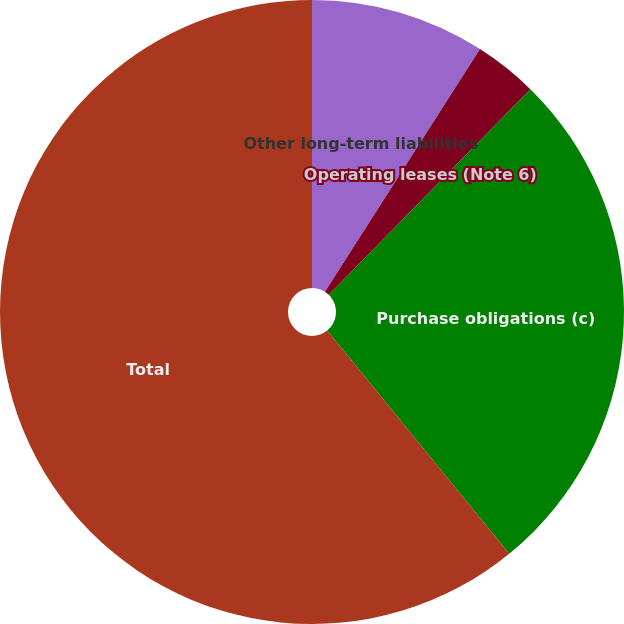<chart> <loc_0><loc_0><loc_500><loc_500><pie_chart><fcel>Other long-term liabilities<fcel>Operating leases (Note 6)<fcel>Purchase obligations (c)<fcel>Total<nl><fcel>9.05%<fcel>3.29%<fcel>26.77%<fcel>60.89%<nl></chart> 